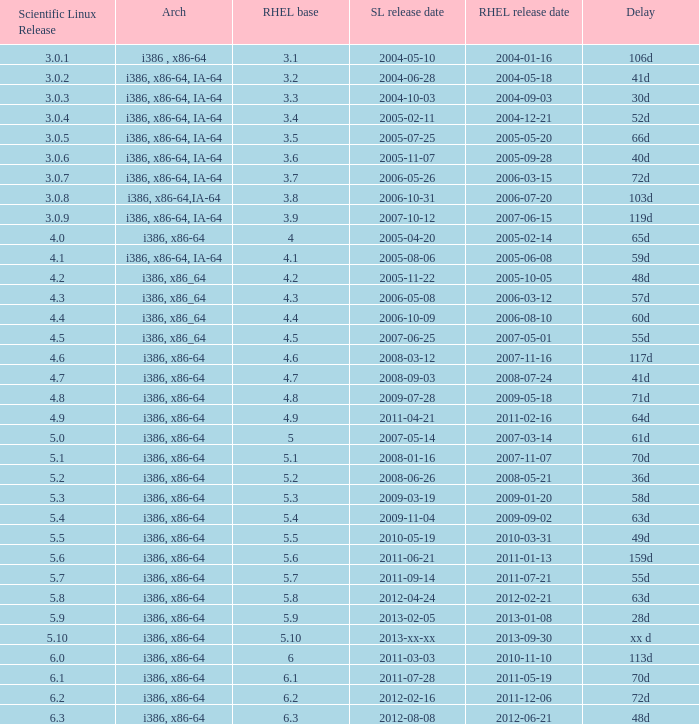When is the rhel release date when scientific linux release is 3.0.4 2004-12-21. 